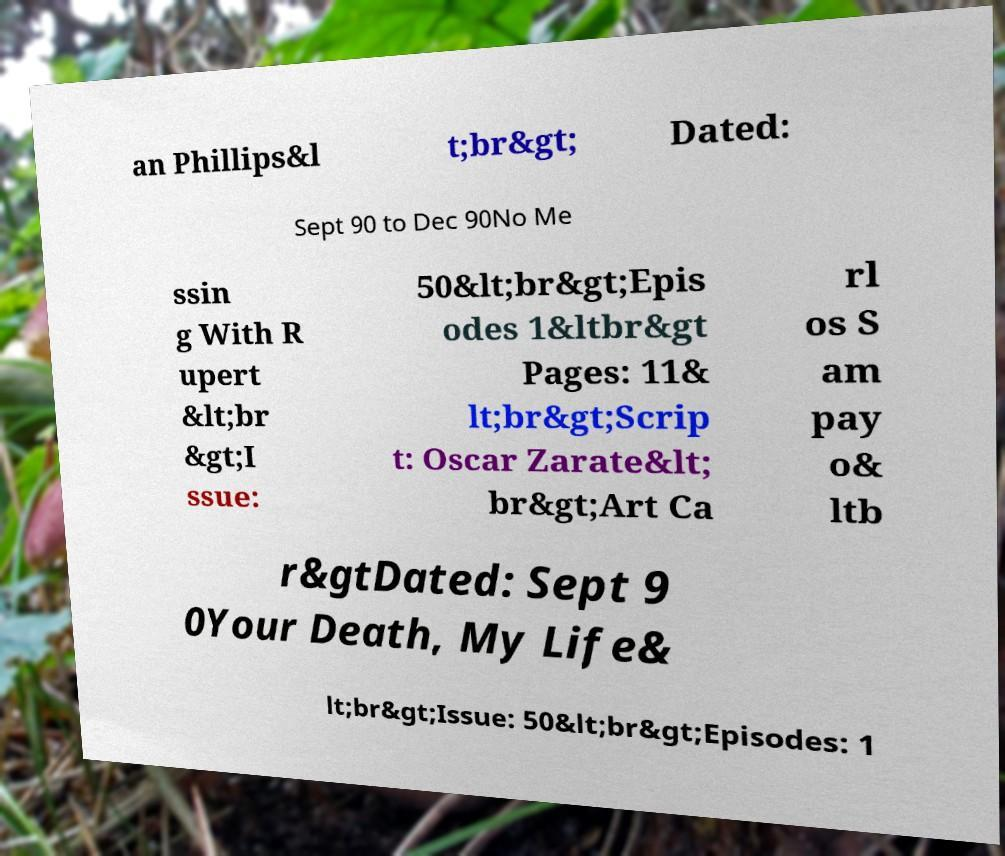Could you extract and type out the text from this image? an Phillips&l t;br&gt; Dated: Sept 90 to Dec 90No Me ssin g With R upert &lt;br &gt;I ssue: 50&lt;br&gt;Epis odes 1&ltbr&gt Pages: 11& lt;br&gt;Scrip t: Oscar Zarate&lt; br&gt;Art Ca rl os S am pay o& ltb r&gtDated: Sept 9 0Your Death, My Life& lt;br&gt;Issue: 50&lt;br&gt;Episodes: 1 